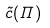Convert formula to latex. <formula><loc_0><loc_0><loc_500><loc_500>\tilde { c } ( \Pi )</formula> 